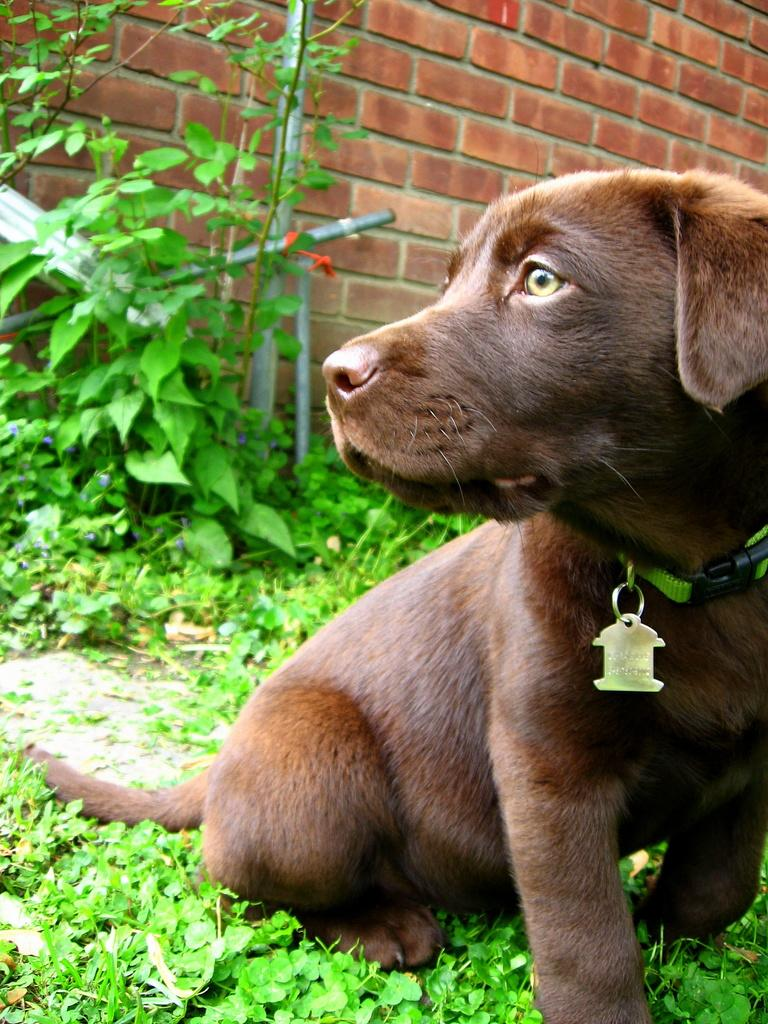What animal can be seen in the image? There is a dog in the image. What is the dog doing in the image? The dog is sitting on the ground. What can be seen in the background of the image? There are trees and a wall in the background of the image. How many geese are flying over the dog in the image? There are no geese present in the image; it only features a dog sitting on the ground and a background with trees and a wall. 